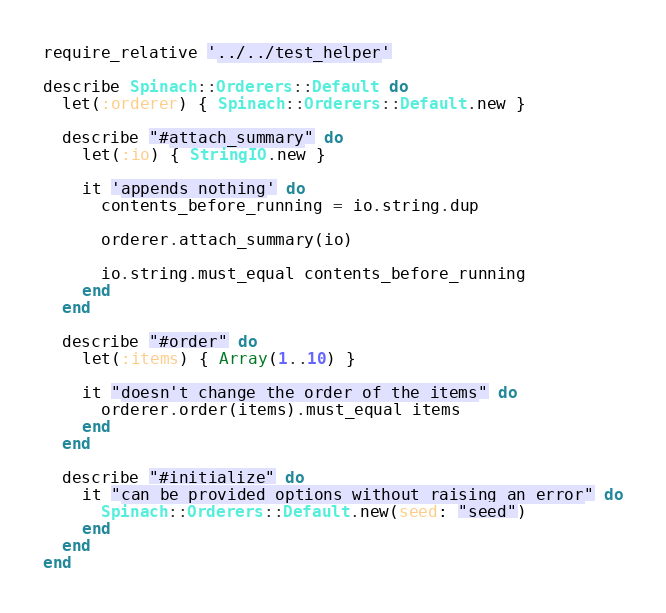Convert code to text. <code><loc_0><loc_0><loc_500><loc_500><_Ruby_>require_relative '../../test_helper'

describe Spinach::Orderers::Default do
  let(:orderer) { Spinach::Orderers::Default.new }

  describe "#attach_summary" do
    let(:io) { StringIO.new }

    it 'appends nothing' do
      contents_before_running = io.string.dup

      orderer.attach_summary(io)

      io.string.must_equal contents_before_running
    end
  end

  describe "#order" do
    let(:items) { Array(1..10) }

    it "doesn't change the order of the items" do
      orderer.order(items).must_equal items
    end
  end

  describe "#initialize" do
    it "can be provided options without raising an error" do
      Spinach::Orderers::Default.new(seed: "seed")
    end
  end
end
</code> 